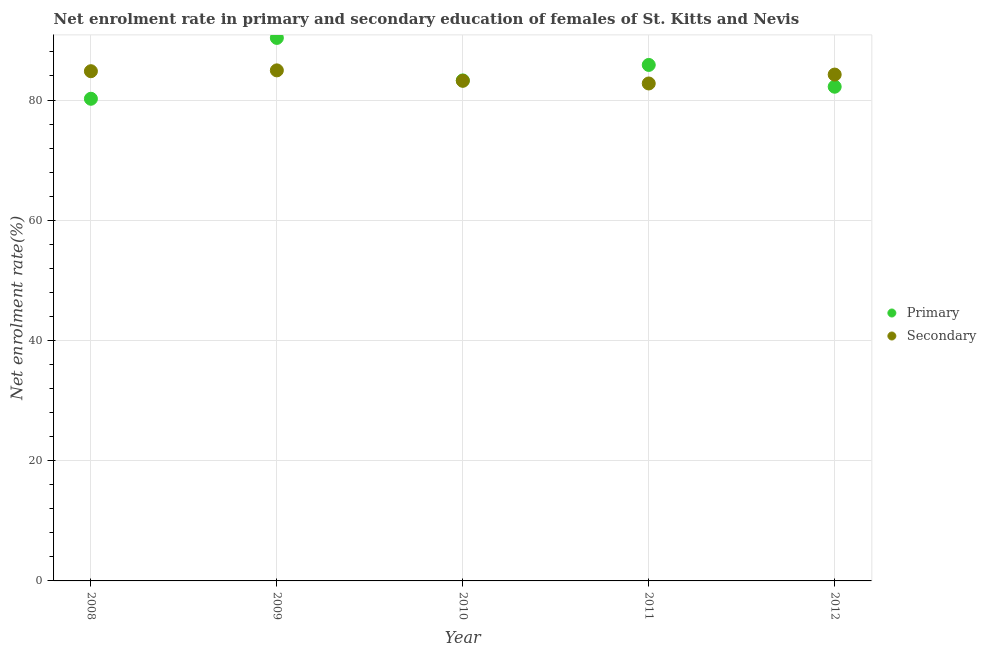How many different coloured dotlines are there?
Give a very brief answer. 2. Is the number of dotlines equal to the number of legend labels?
Give a very brief answer. Yes. What is the enrollment rate in secondary education in 2010?
Keep it short and to the point. 83.2. Across all years, what is the maximum enrollment rate in primary education?
Ensure brevity in your answer.  90.33. Across all years, what is the minimum enrollment rate in secondary education?
Provide a succinct answer. 82.76. In which year was the enrollment rate in secondary education maximum?
Keep it short and to the point. 2009. In which year was the enrollment rate in primary education minimum?
Give a very brief answer. 2008. What is the total enrollment rate in primary education in the graph?
Offer a terse response. 421.86. What is the difference between the enrollment rate in secondary education in 2008 and that in 2011?
Offer a terse response. 2.04. What is the difference between the enrollment rate in primary education in 2010 and the enrollment rate in secondary education in 2012?
Ensure brevity in your answer.  -0.97. What is the average enrollment rate in secondary education per year?
Keep it short and to the point. 83.98. In the year 2011, what is the difference between the enrollment rate in primary education and enrollment rate in secondary education?
Offer a very short reply. 3.09. What is the ratio of the enrollment rate in secondary education in 2009 to that in 2012?
Your answer should be very brief. 1.01. Is the enrollment rate in primary education in 2010 less than that in 2011?
Your answer should be compact. Yes. Is the difference between the enrollment rate in secondary education in 2008 and 2010 greater than the difference between the enrollment rate in primary education in 2008 and 2010?
Make the answer very short. Yes. What is the difference between the highest and the second highest enrollment rate in primary education?
Provide a short and direct response. 4.49. What is the difference between the highest and the lowest enrollment rate in primary education?
Give a very brief answer. 10.12. In how many years, is the enrollment rate in secondary education greater than the average enrollment rate in secondary education taken over all years?
Make the answer very short. 3. Does the enrollment rate in secondary education monotonically increase over the years?
Your answer should be compact. No. Is the enrollment rate in primary education strictly greater than the enrollment rate in secondary education over the years?
Offer a very short reply. No. Are the values on the major ticks of Y-axis written in scientific E-notation?
Provide a short and direct response. No. Does the graph contain any zero values?
Offer a very short reply. No. How many legend labels are there?
Offer a terse response. 2. What is the title of the graph?
Make the answer very short. Net enrolment rate in primary and secondary education of females of St. Kitts and Nevis. What is the label or title of the Y-axis?
Ensure brevity in your answer.  Net enrolment rate(%). What is the Net enrolment rate(%) of Primary in 2008?
Offer a terse response. 80.21. What is the Net enrolment rate(%) of Secondary in 2008?
Ensure brevity in your answer.  84.8. What is the Net enrolment rate(%) of Primary in 2009?
Provide a short and direct response. 90.33. What is the Net enrolment rate(%) in Secondary in 2009?
Provide a succinct answer. 84.94. What is the Net enrolment rate(%) of Primary in 2010?
Your answer should be very brief. 83.26. What is the Net enrolment rate(%) in Secondary in 2010?
Provide a succinct answer. 83.2. What is the Net enrolment rate(%) in Primary in 2011?
Provide a succinct answer. 85.84. What is the Net enrolment rate(%) of Secondary in 2011?
Provide a succinct answer. 82.76. What is the Net enrolment rate(%) in Primary in 2012?
Offer a very short reply. 82.21. What is the Net enrolment rate(%) in Secondary in 2012?
Your answer should be very brief. 84.24. Across all years, what is the maximum Net enrolment rate(%) of Primary?
Offer a terse response. 90.33. Across all years, what is the maximum Net enrolment rate(%) in Secondary?
Ensure brevity in your answer.  84.94. Across all years, what is the minimum Net enrolment rate(%) in Primary?
Give a very brief answer. 80.21. Across all years, what is the minimum Net enrolment rate(%) of Secondary?
Ensure brevity in your answer.  82.76. What is the total Net enrolment rate(%) in Primary in the graph?
Offer a very short reply. 421.86. What is the total Net enrolment rate(%) in Secondary in the graph?
Provide a succinct answer. 419.92. What is the difference between the Net enrolment rate(%) in Primary in 2008 and that in 2009?
Give a very brief answer. -10.12. What is the difference between the Net enrolment rate(%) of Secondary in 2008 and that in 2009?
Give a very brief answer. -0.14. What is the difference between the Net enrolment rate(%) of Primary in 2008 and that in 2010?
Give a very brief answer. -3.05. What is the difference between the Net enrolment rate(%) in Secondary in 2008 and that in 2010?
Offer a terse response. 1.6. What is the difference between the Net enrolment rate(%) of Primary in 2008 and that in 2011?
Your answer should be compact. -5.63. What is the difference between the Net enrolment rate(%) in Secondary in 2008 and that in 2011?
Provide a short and direct response. 2.04. What is the difference between the Net enrolment rate(%) of Primary in 2008 and that in 2012?
Your answer should be compact. -2. What is the difference between the Net enrolment rate(%) in Secondary in 2008 and that in 2012?
Your answer should be very brief. 0.56. What is the difference between the Net enrolment rate(%) in Primary in 2009 and that in 2010?
Keep it short and to the point. 7.07. What is the difference between the Net enrolment rate(%) of Secondary in 2009 and that in 2010?
Make the answer very short. 1.74. What is the difference between the Net enrolment rate(%) in Primary in 2009 and that in 2011?
Make the answer very short. 4.49. What is the difference between the Net enrolment rate(%) in Secondary in 2009 and that in 2011?
Make the answer very short. 2.18. What is the difference between the Net enrolment rate(%) of Primary in 2009 and that in 2012?
Ensure brevity in your answer.  8.12. What is the difference between the Net enrolment rate(%) of Secondary in 2009 and that in 2012?
Provide a short and direct response. 0.7. What is the difference between the Net enrolment rate(%) of Primary in 2010 and that in 2011?
Provide a succinct answer. -2.58. What is the difference between the Net enrolment rate(%) in Secondary in 2010 and that in 2011?
Offer a very short reply. 0.44. What is the difference between the Net enrolment rate(%) of Primary in 2010 and that in 2012?
Offer a very short reply. 1.05. What is the difference between the Net enrolment rate(%) of Secondary in 2010 and that in 2012?
Make the answer very short. -1.04. What is the difference between the Net enrolment rate(%) in Primary in 2011 and that in 2012?
Keep it short and to the point. 3.63. What is the difference between the Net enrolment rate(%) of Secondary in 2011 and that in 2012?
Give a very brief answer. -1.48. What is the difference between the Net enrolment rate(%) in Primary in 2008 and the Net enrolment rate(%) in Secondary in 2009?
Ensure brevity in your answer.  -4.72. What is the difference between the Net enrolment rate(%) of Primary in 2008 and the Net enrolment rate(%) of Secondary in 2010?
Give a very brief answer. -2.99. What is the difference between the Net enrolment rate(%) of Primary in 2008 and the Net enrolment rate(%) of Secondary in 2011?
Offer a terse response. -2.54. What is the difference between the Net enrolment rate(%) in Primary in 2008 and the Net enrolment rate(%) in Secondary in 2012?
Make the answer very short. -4.03. What is the difference between the Net enrolment rate(%) in Primary in 2009 and the Net enrolment rate(%) in Secondary in 2010?
Your answer should be compact. 7.13. What is the difference between the Net enrolment rate(%) of Primary in 2009 and the Net enrolment rate(%) of Secondary in 2011?
Offer a very short reply. 7.58. What is the difference between the Net enrolment rate(%) in Primary in 2009 and the Net enrolment rate(%) in Secondary in 2012?
Give a very brief answer. 6.1. What is the difference between the Net enrolment rate(%) in Primary in 2010 and the Net enrolment rate(%) in Secondary in 2011?
Provide a succinct answer. 0.51. What is the difference between the Net enrolment rate(%) in Primary in 2010 and the Net enrolment rate(%) in Secondary in 2012?
Provide a succinct answer. -0.97. What is the difference between the Net enrolment rate(%) of Primary in 2011 and the Net enrolment rate(%) of Secondary in 2012?
Make the answer very short. 1.6. What is the average Net enrolment rate(%) of Primary per year?
Offer a very short reply. 84.37. What is the average Net enrolment rate(%) of Secondary per year?
Offer a terse response. 83.98. In the year 2008, what is the difference between the Net enrolment rate(%) in Primary and Net enrolment rate(%) in Secondary?
Offer a terse response. -4.59. In the year 2009, what is the difference between the Net enrolment rate(%) of Primary and Net enrolment rate(%) of Secondary?
Offer a terse response. 5.4. In the year 2010, what is the difference between the Net enrolment rate(%) of Primary and Net enrolment rate(%) of Secondary?
Your response must be concise. 0.06. In the year 2011, what is the difference between the Net enrolment rate(%) of Primary and Net enrolment rate(%) of Secondary?
Give a very brief answer. 3.09. In the year 2012, what is the difference between the Net enrolment rate(%) in Primary and Net enrolment rate(%) in Secondary?
Keep it short and to the point. -2.02. What is the ratio of the Net enrolment rate(%) of Primary in 2008 to that in 2009?
Keep it short and to the point. 0.89. What is the ratio of the Net enrolment rate(%) of Secondary in 2008 to that in 2009?
Ensure brevity in your answer.  1. What is the ratio of the Net enrolment rate(%) in Primary in 2008 to that in 2010?
Keep it short and to the point. 0.96. What is the ratio of the Net enrolment rate(%) in Secondary in 2008 to that in 2010?
Your answer should be very brief. 1.02. What is the ratio of the Net enrolment rate(%) of Primary in 2008 to that in 2011?
Give a very brief answer. 0.93. What is the ratio of the Net enrolment rate(%) of Secondary in 2008 to that in 2011?
Your answer should be very brief. 1.02. What is the ratio of the Net enrolment rate(%) in Primary in 2008 to that in 2012?
Your response must be concise. 0.98. What is the ratio of the Net enrolment rate(%) of Secondary in 2008 to that in 2012?
Give a very brief answer. 1.01. What is the ratio of the Net enrolment rate(%) of Primary in 2009 to that in 2010?
Offer a terse response. 1.08. What is the ratio of the Net enrolment rate(%) of Secondary in 2009 to that in 2010?
Provide a succinct answer. 1.02. What is the ratio of the Net enrolment rate(%) of Primary in 2009 to that in 2011?
Your answer should be very brief. 1.05. What is the ratio of the Net enrolment rate(%) in Secondary in 2009 to that in 2011?
Your response must be concise. 1.03. What is the ratio of the Net enrolment rate(%) in Primary in 2009 to that in 2012?
Make the answer very short. 1.1. What is the ratio of the Net enrolment rate(%) of Secondary in 2009 to that in 2012?
Ensure brevity in your answer.  1.01. What is the ratio of the Net enrolment rate(%) of Secondary in 2010 to that in 2011?
Provide a short and direct response. 1.01. What is the ratio of the Net enrolment rate(%) of Primary in 2010 to that in 2012?
Give a very brief answer. 1.01. What is the ratio of the Net enrolment rate(%) in Primary in 2011 to that in 2012?
Provide a succinct answer. 1.04. What is the ratio of the Net enrolment rate(%) in Secondary in 2011 to that in 2012?
Your answer should be very brief. 0.98. What is the difference between the highest and the second highest Net enrolment rate(%) of Primary?
Give a very brief answer. 4.49. What is the difference between the highest and the second highest Net enrolment rate(%) of Secondary?
Provide a succinct answer. 0.14. What is the difference between the highest and the lowest Net enrolment rate(%) of Primary?
Make the answer very short. 10.12. What is the difference between the highest and the lowest Net enrolment rate(%) of Secondary?
Your response must be concise. 2.18. 